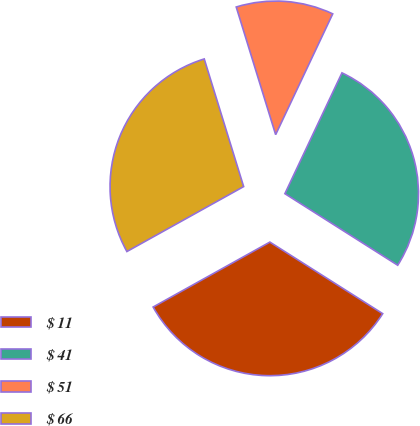Convert chart. <chart><loc_0><loc_0><loc_500><loc_500><pie_chart><fcel>$ 11<fcel>$ 41<fcel>$ 51<fcel>$ 66<nl><fcel>32.92%<fcel>26.97%<fcel>11.79%<fcel>28.31%<nl></chart> 